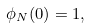Convert formula to latex. <formula><loc_0><loc_0><loc_500><loc_500>\phi _ { N } ( 0 ) = 1 ,</formula> 